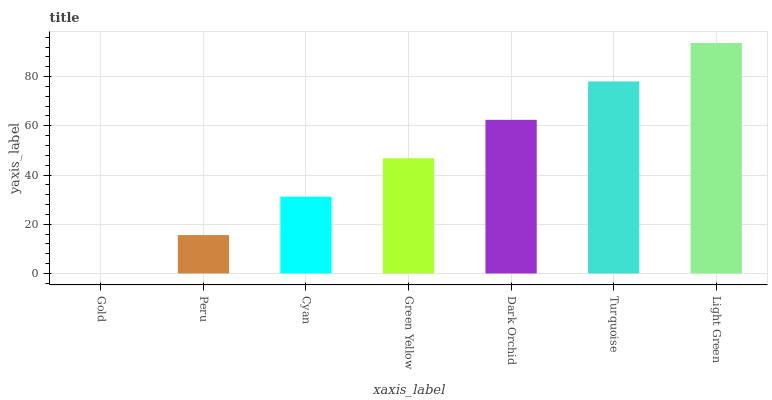Is Gold the minimum?
Answer yes or no. Yes. Is Light Green the maximum?
Answer yes or no. Yes. Is Peru the minimum?
Answer yes or no. No. Is Peru the maximum?
Answer yes or no. No. Is Peru greater than Gold?
Answer yes or no. Yes. Is Gold less than Peru?
Answer yes or no. Yes. Is Gold greater than Peru?
Answer yes or no. No. Is Peru less than Gold?
Answer yes or no. No. Is Green Yellow the high median?
Answer yes or no. Yes. Is Green Yellow the low median?
Answer yes or no. Yes. Is Gold the high median?
Answer yes or no. No. Is Dark Orchid the low median?
Answer yes or no. No. 